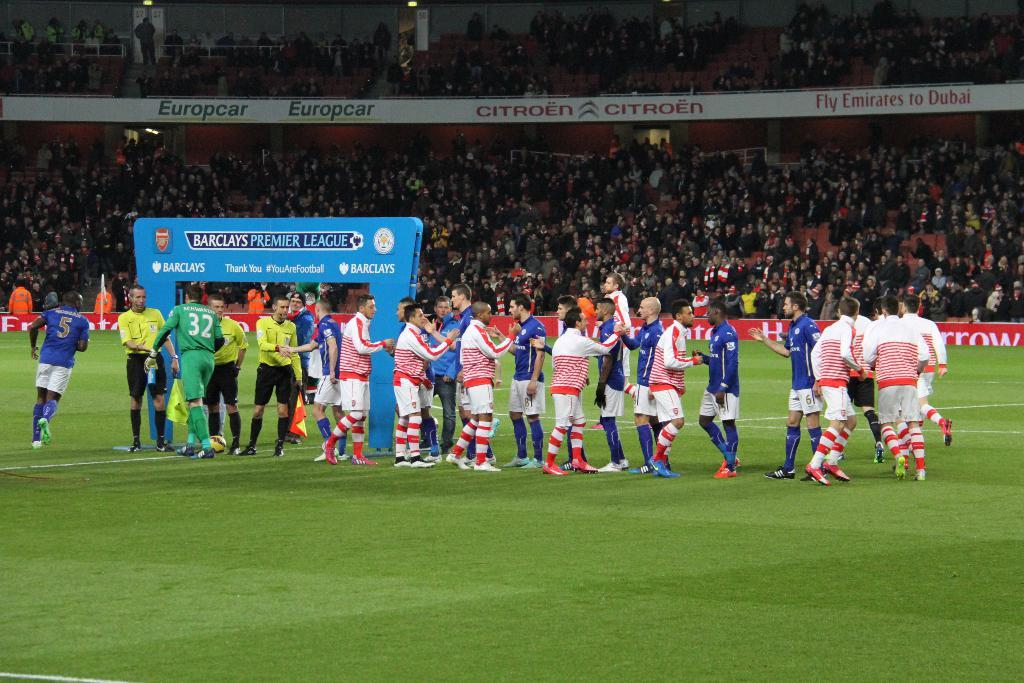<image>
Share a concise interpretation of the image provided. A Barclays Premier League sign is hanging at a stadium. 